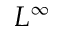Convert formula to latex. <formula><loc_0><loc_0><loc_500><loc_500>L ^ { \infty }</formula> 